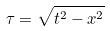Convert formula to latex. <formula><loc_0><loc_0><loc_500><loc_500>\tau = \sqrt { t ^ { 2 } - x ^ { 2 } }</formula> 